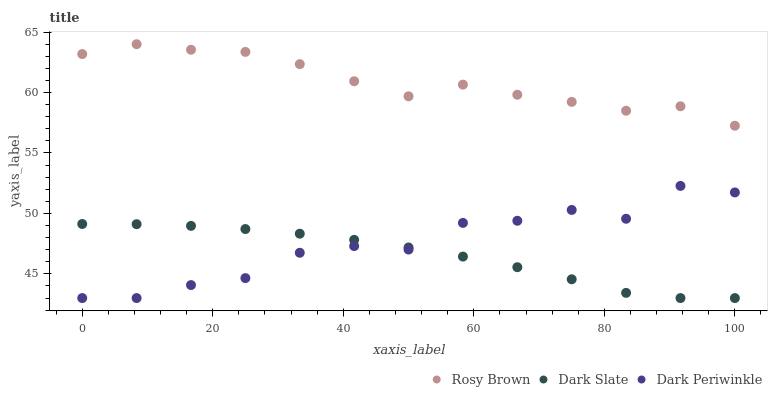Does Dark Slate have the minimum area under the curve?
Answer yes or no. Yes. Does Rosy Brown have the maximum area under the curve?
Answer yes or no. Yes. Does Dark Periwinkle have the minimum area under the curve?
Answer yes or no. No. Does Dark Periwinkle have the maximum area under the curve?
Answer yes or no. No. Is Dark Slate the smoothest?
Answer yes or no. Yes. Is Dark Periwinkle the roughest?
Answer yes or no. Yes. Is Rosy Brown the smoothest?
Answer yes or no. No. Is Rosy Brown the roughest?
Answer yes or no. No. Does Dark Slate have the lowest value?
Answer yes or no. Yes. Does Rosy Brown have the lowest value?
Answer yes or no. No. Does Rosy Brown have the highest value?
Answer yes or no. Yes. Does Dark Periwinkle have the highest value?
Answer yes or no. No. Is Dark Periwinkle less than Rosy Brown?
Answer yes or no. Yes. Is Rosy Brown greater than Dark Slate?
Answer yes or no. Yes. Does Dark Periwinkle intersect Dark Slate?
Answer yes or no. Yes. Is Dark Periwinkle less than Dark Slate?
Answer yes or no. No. Is Dark Periwinkle greater than Dark Slate?
Answer yes or no. No. Does Dark Periwinkle intersect Rosy Brown?
Answer yes or no. No. 